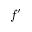Convert formula to latex. <formula><loc_0><loc_0><loc_500><loc_500>f ^ { \prime }</formula> 